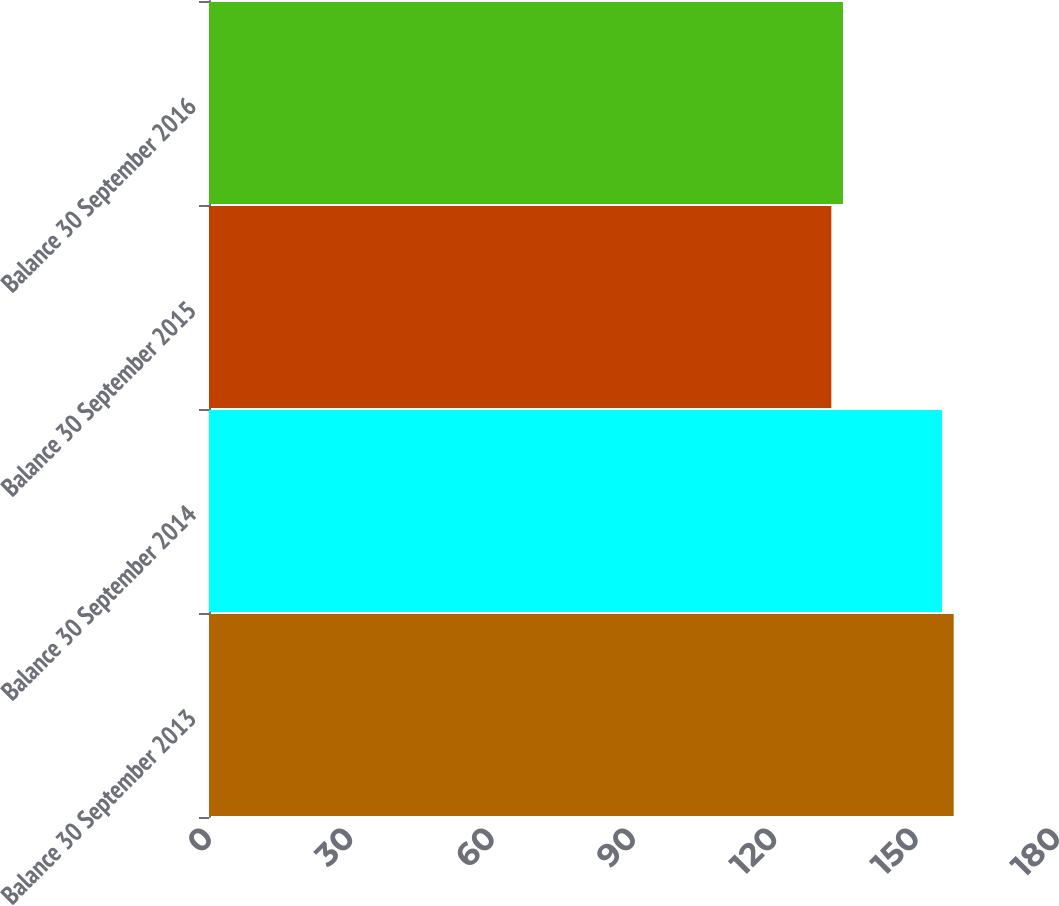Convert chart to OTSL. <chart><loc_0><loc_0><loc_500><loc_500><bar_chart><fcel>Balance 30 September 2013<fcel>Balance 30 September 2014<fcel>Balance 30 September 2015<fcel>Balance 30 September 2016<nl><fcel>158.07<fcel>155.6<fcel>132.1<fcel>134.57<nl></chart> 